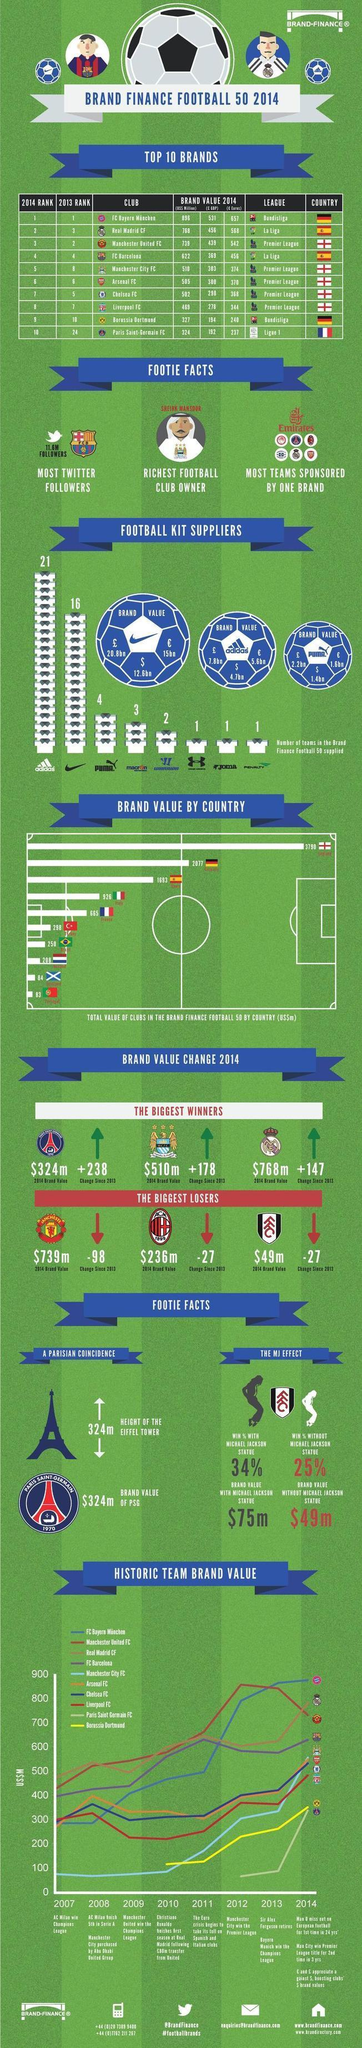How much is the brand value of Adidas in euro?
Answer the question with a short phrase. 5.6bn What is the color code given to the team Borussia Dortmund- red, violet, yellow, black? yellow What is the brand value of NIKE in dollars? 12.6bn Which country's football club has the fourth-highest brand value? Italy Which are the clubs participating in the La Liga league? Real Madrid CF, FC Barcelona How much is the brand value of Puma in Pound? 2.2bn How many clubs listed participate in the La Liga league? 2 How many teams have crossed the 700US$M brand value? 3 Which Football team's brand value was at the top in 2012? Manchester United FC 